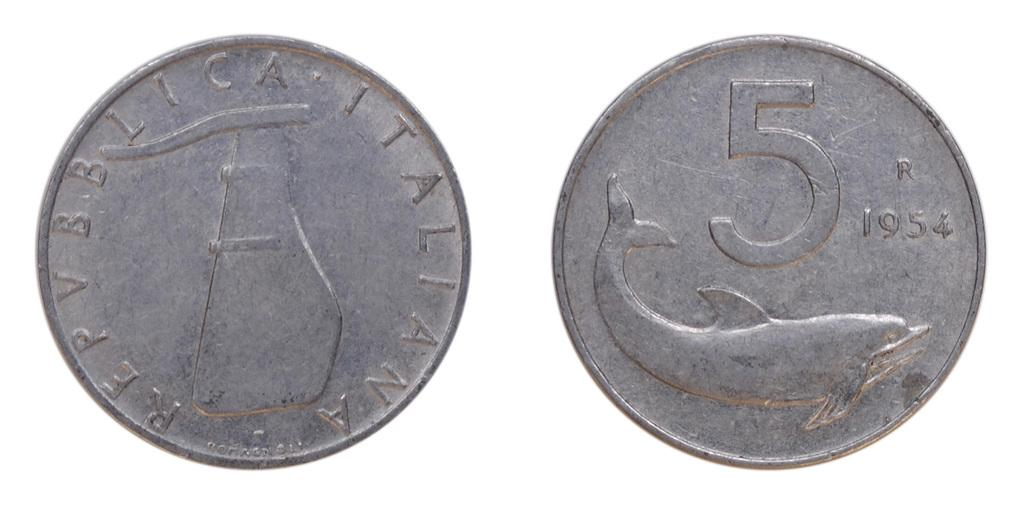<image>
Provide a brief description of the given image. two, 5 cent italian coins from the year 1954. 